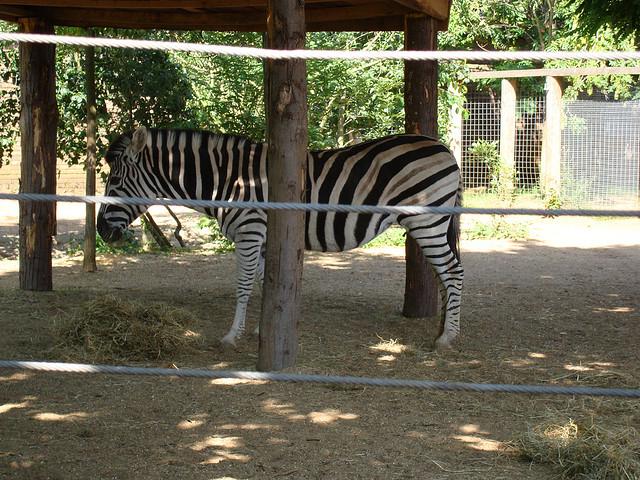What 3 brown objects are around the zebra?
Quick response, please. Posts. What is the zebra eating?
Be succinct. Hay. Is the zebra free to roam wherever it desires?
Answer briefly. No. 